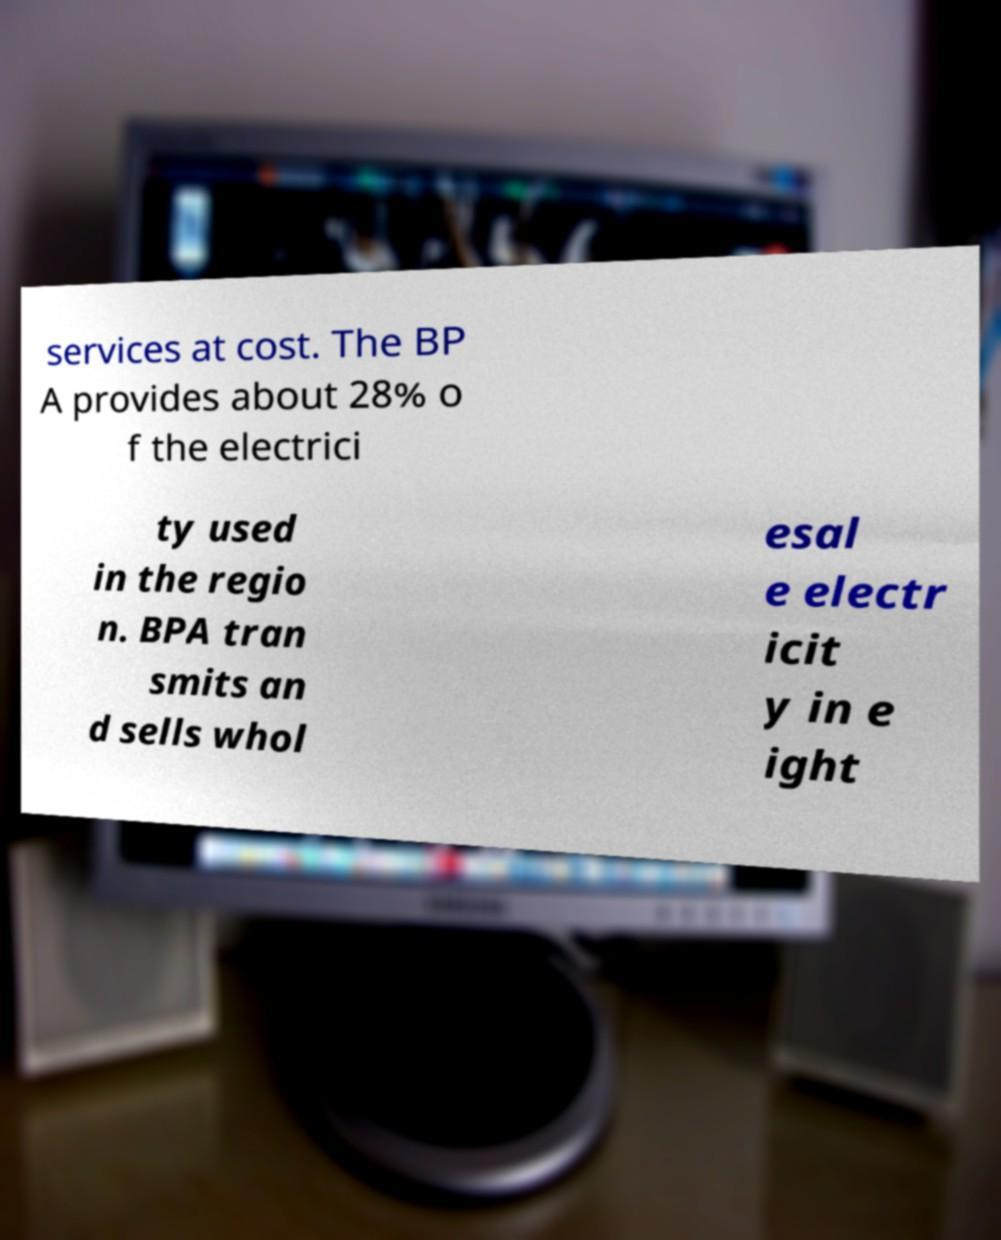What messages or text are displayed in this image? I need them in a readable, typed format. services at cost. The BP A provides about 28% o f the electrici ty used in the regio n. BPA tran smits an d sells whol esal e electr icit y in e ight 